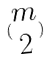Convert formula to latex. <formula><loc_0><loc_0><loc_500><loc_500>( \begin{matrix} m \\ 2 \end{matrix} )</formula> 